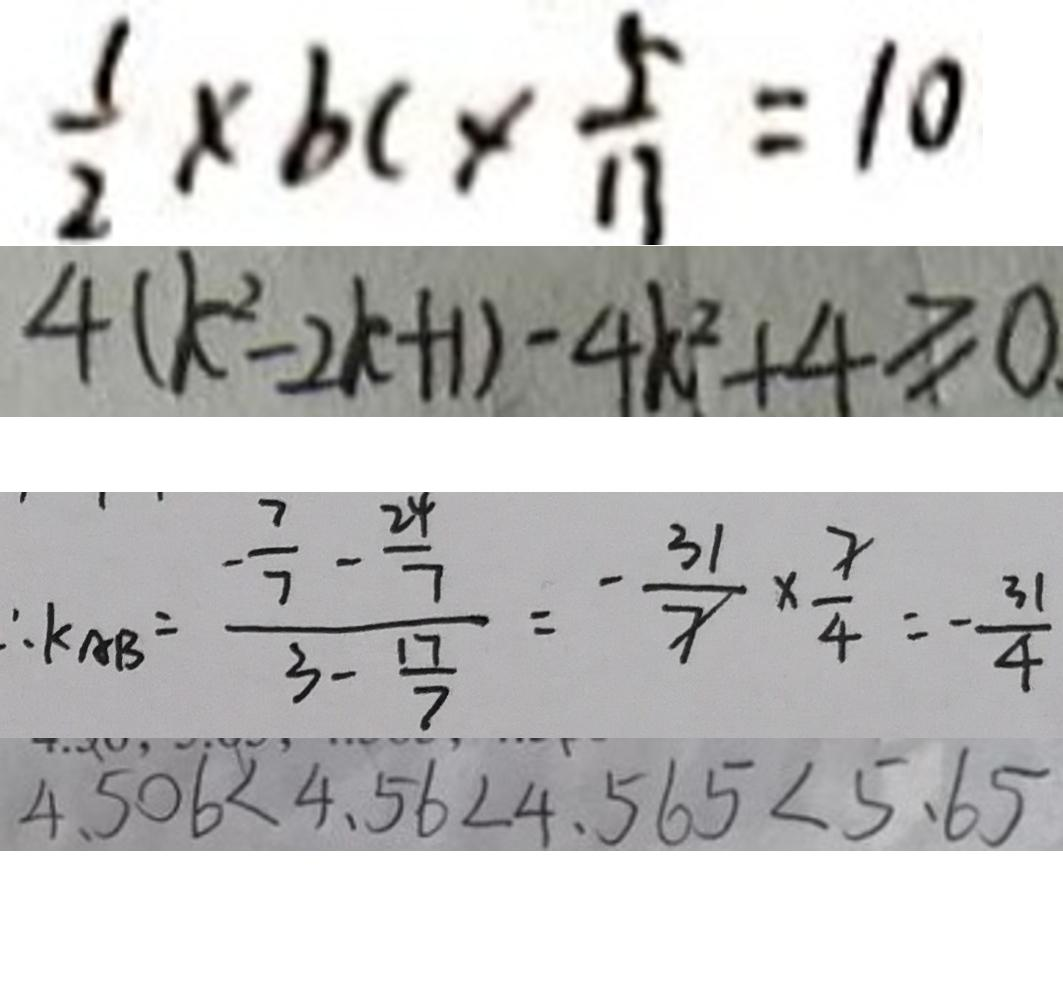Convert formula to latex. <formula><loc_0><loc_0><loc_500><loc_500>\frac { 1 } { 2 } \times b c \times \frac { 5 } { 1 1 } = 1 0 
 4 ( k ^ { 2 } - 2 k + 1 ) - 4 k ^ { 2 } + 4 \geq 0 . 
 \therefore k _ { A B } = \frac { - \frac { 7 } { 7 } - \frac { 2 4 } { 7 } } { 3 - \frac { 1 7 } { 7 } } = - \frac { 3 1 } { 7 } \times \frac { 7 } { 4 } = - \frac { 3 1 } { 4 } 
 4 . 5 0 \dot { 6 } < 4 . 5 6 < 4 . 5 6 5 < 5 . 6 5</formula> 